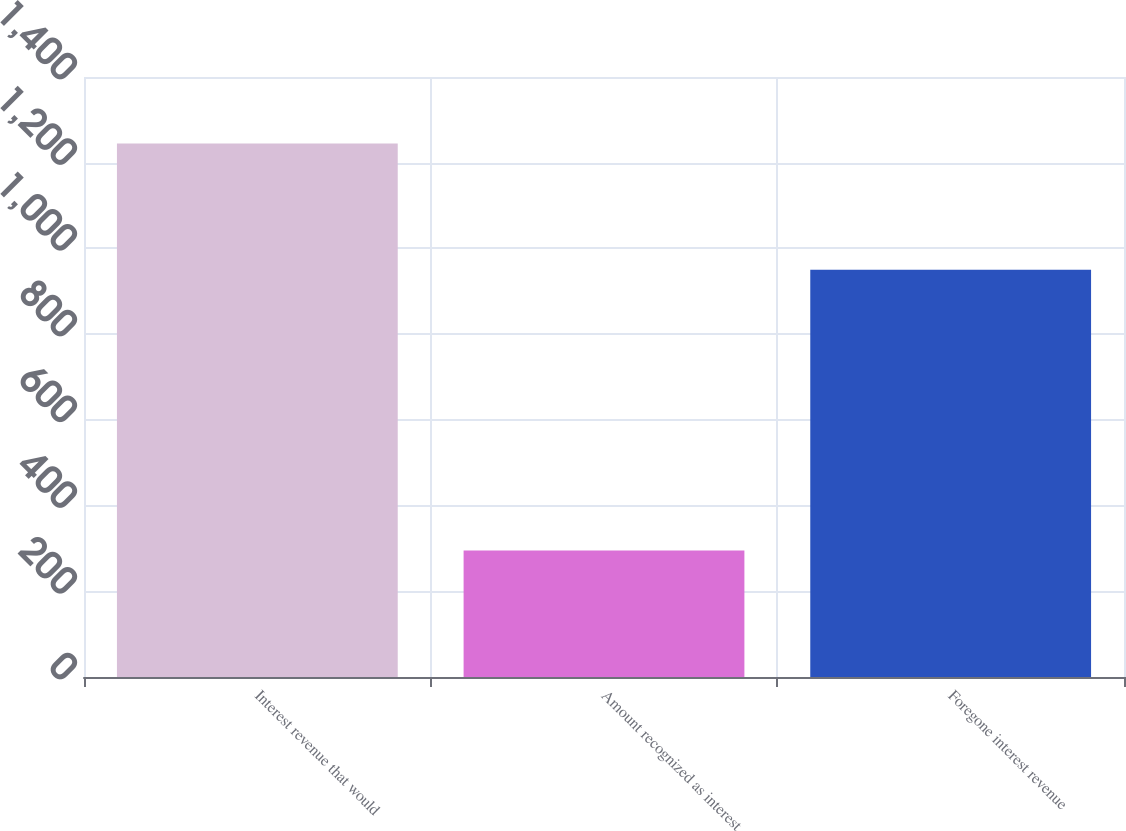<chart> <loc_0><loc_0><loc_500><loc_500><bar_chart><fcel>Interest revenue that would<fcel>Amount recognized as interest<fcel>Foregone interest revenue<nl><fcel>1245<fcel>295<fcel>950<nl></chart> 